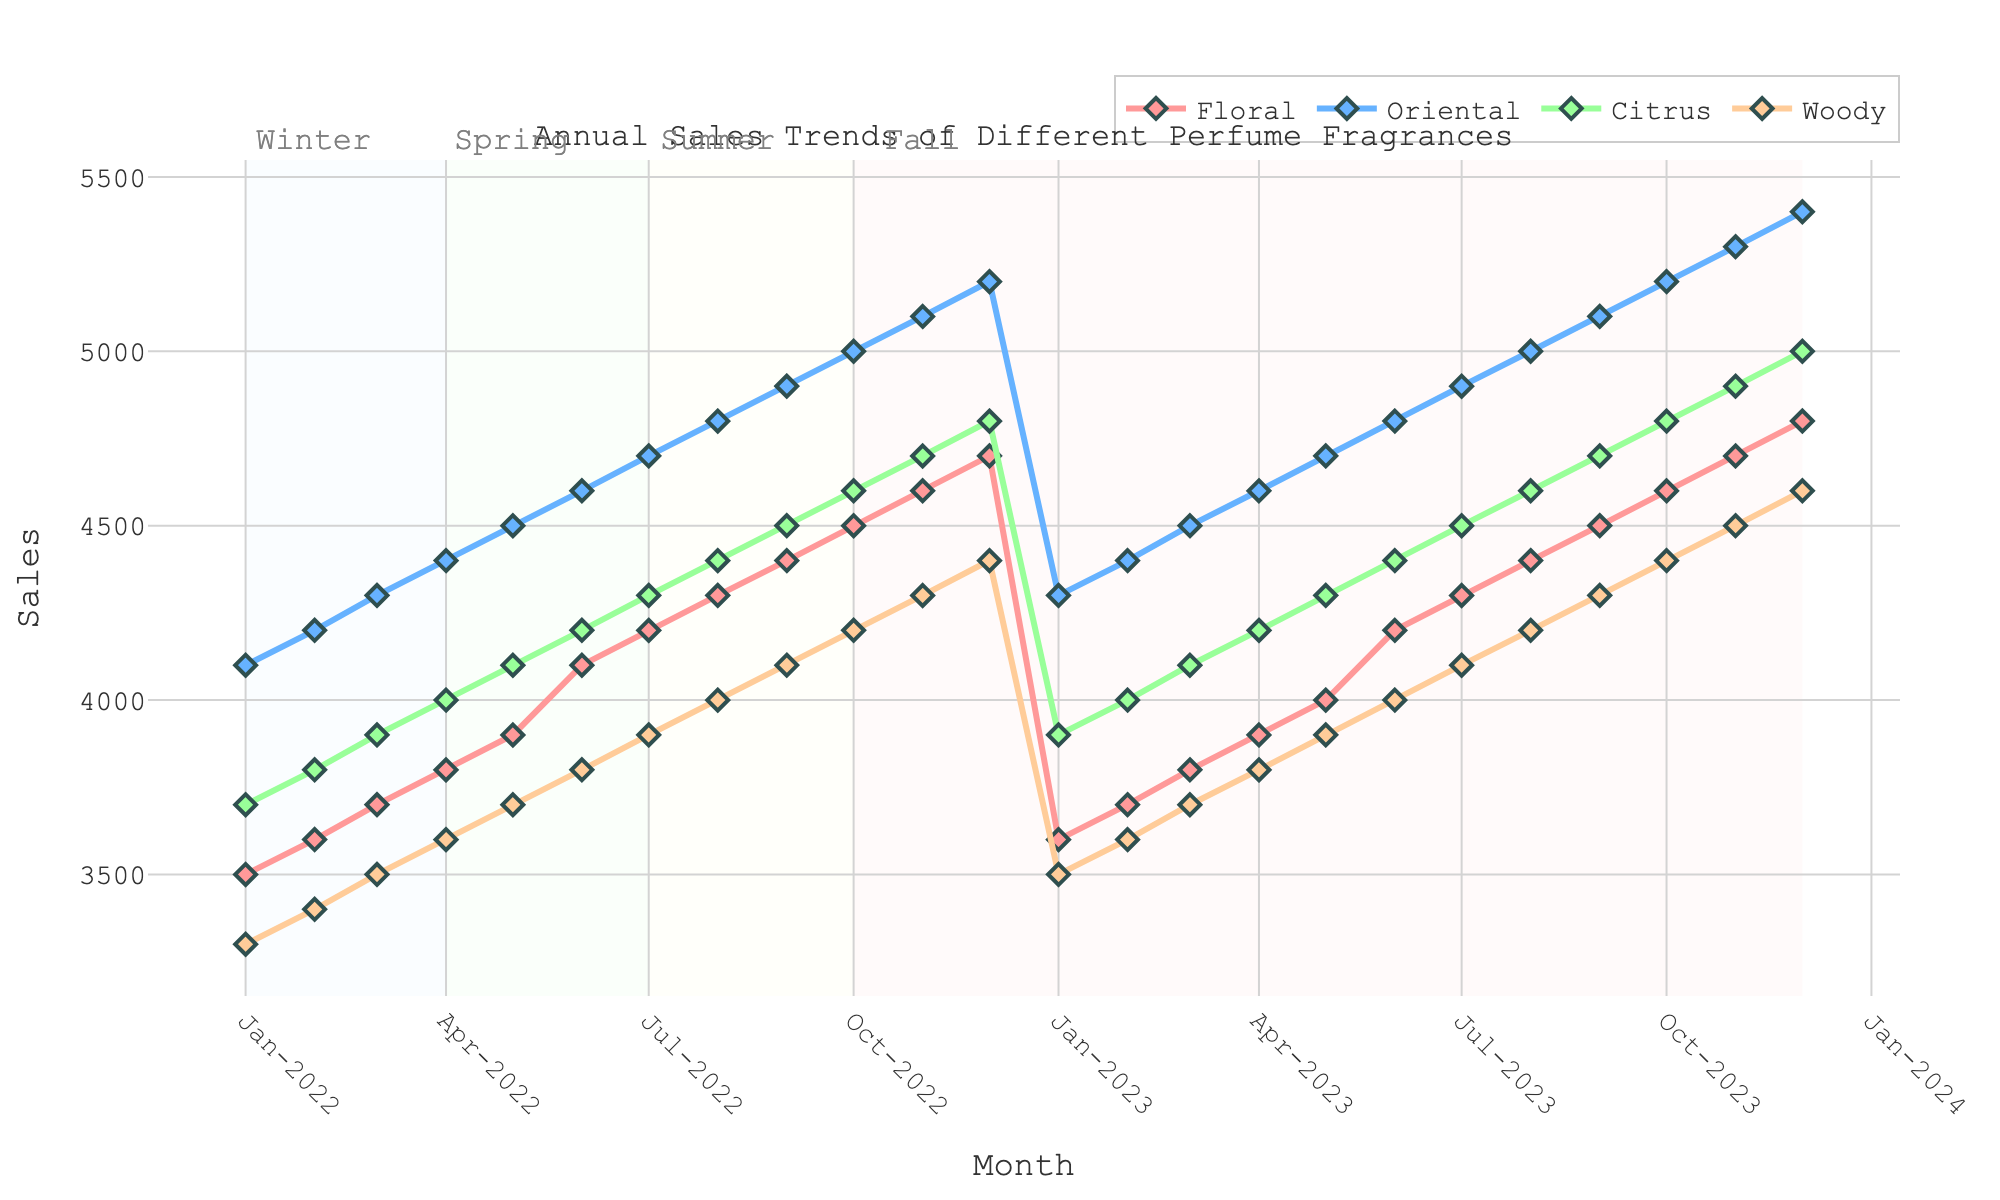What is the title of the plot? The title of the plot is displayed at the top, which reads "Annual Sales Trends of Different Perfume Fragrances."
Answer: Annual Sales Trends of Different Perfume Fragrances Which fragrance had the highest sales in December 2023? In December 2023, observe the sales values for each fragrance. The fragrance with the highest sales is Oriental, indicated by the highest point on the y-axis in that month.
Answer: Oriental What is the color of the line representing the Citrus fragrance? On the plot, the Citrus fragrance line is represented in a distinct color. This line is shown in green.
Answer: Green Between which months is Spring represented with a colored background? From the plot, identify the section shaded for Spring. It spans from March to May.
Answer: March to May How do the trends of Floral and Woody fragrances compare from January to December 2022? For Floral and Woody, track their lines from January to December 2022. Floral fragrance sales consistently increase, while Woody sales also increase but start at a lower value and rise at a similar rate.
Answer: Both increase; Floral starts higher and remains higher What is the difference between the highest and lowest sales of the Floral fragrance in 2022? Identify the highest point (December, 4700) and lowest point (January, 3500) for the Floral fragrance in 2022. Subtract the lowest from the highest: 4700 - 3500
Answer: 1200 Which season shows the overall highest sales for the Oriental fragrance? Check the shaded regions representing seasons and compare Oriental fragrance sales. The highest overall sales for Oriental fragrance occur during Fall.
Answer: Fall In which month of 2023 do all fragrances show the lowest sales? For the year 2023, inspect the monthly sales trends. The lowest sales across all fragrances occur in January 2023.
Answer: January How do the sales trends of Citrus and Oriental fragrances compare in the summer of 2023? Summer months are June, July, and August. Compare Citrus and Oriental sales trends: both fragrances show increasing sales, with Oriental consistently higher.
Answer: Both increase; Oriental consistently higher What is the average sales value for Woody fragrance in 2023? Calculate the average by summing the sales of Woody fragrance each month in 2023 (3500, 3600, ..., 4600) then divide by the number of months. (Sum = 47400, months = 12), so 47400/12 = 3950.
Answer: 3950 